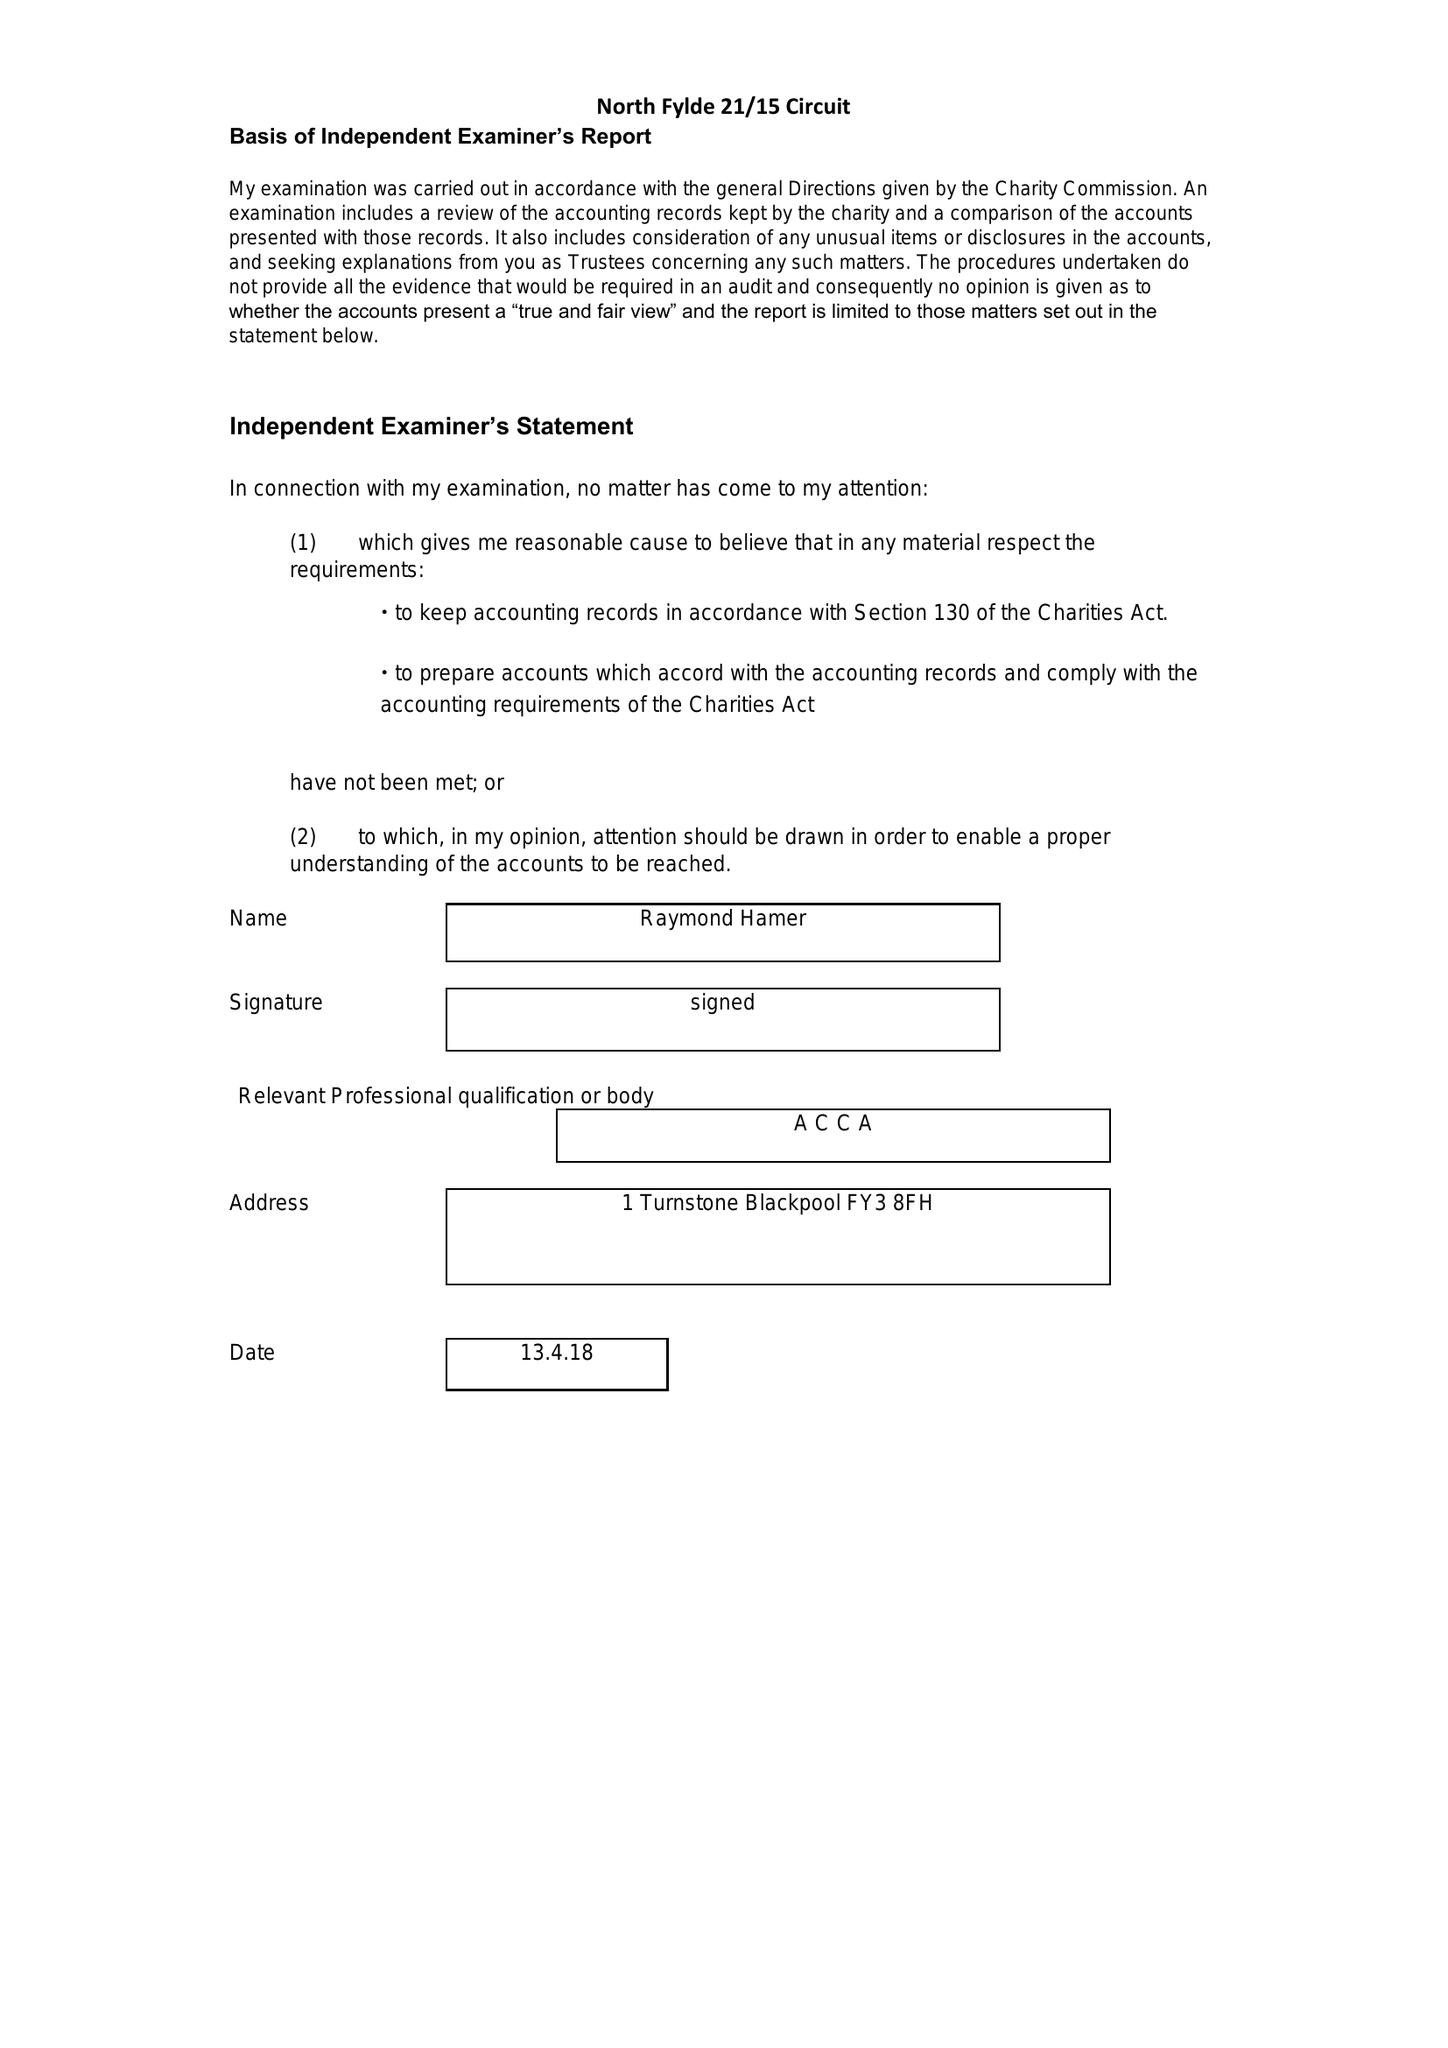What is the value for the report_date?
Answer the question using a single word or phrase. 2017-08-31 